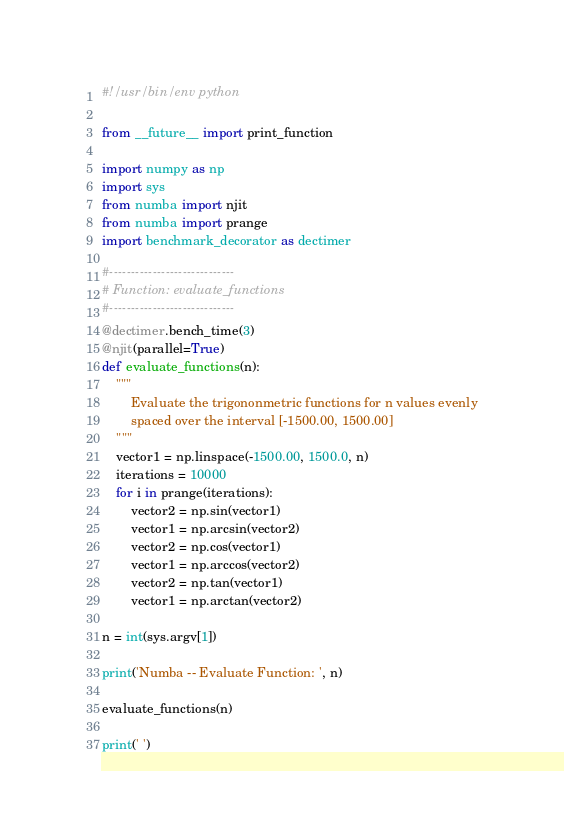<code> <loc_0><loc_0><loc_500><loc_500><_Python_>#!/usr/bin/env python

from __future__ import print_function

import numpy as np
import sys
from numba import njit
from numba import prange
import benchmark_decorator as dectimer

#-----------------------------
# Function: evaluate_functions
#-----------------------------
@dectimer.bench_time(3)
@njit(parallel=True)
def evaluate_functions(n):
    """
        Evaluate the trigononmetric functions for n values evenly
        spaced over the interval [-1500.00, 1500.00]
    """
    vector1 = np.linspace(-1500.00, 1500.0, n)
    iterations = 10000
    for i in prange(iterations):
        vector2 = np.sin(vector1)
        vector1 = np.arcsin(vector2)
        vector2 = np.cos(vector1)
        vector1 = np.arccos(vector2)
        vector2 = np.tan(vector1)
        vector1 = np.arctan(vector2)

n = int(sys.argv[1])

print('Numba -- Evaluate Function: ', n)

evaluate_functions(n)

print(' ')
</code> 